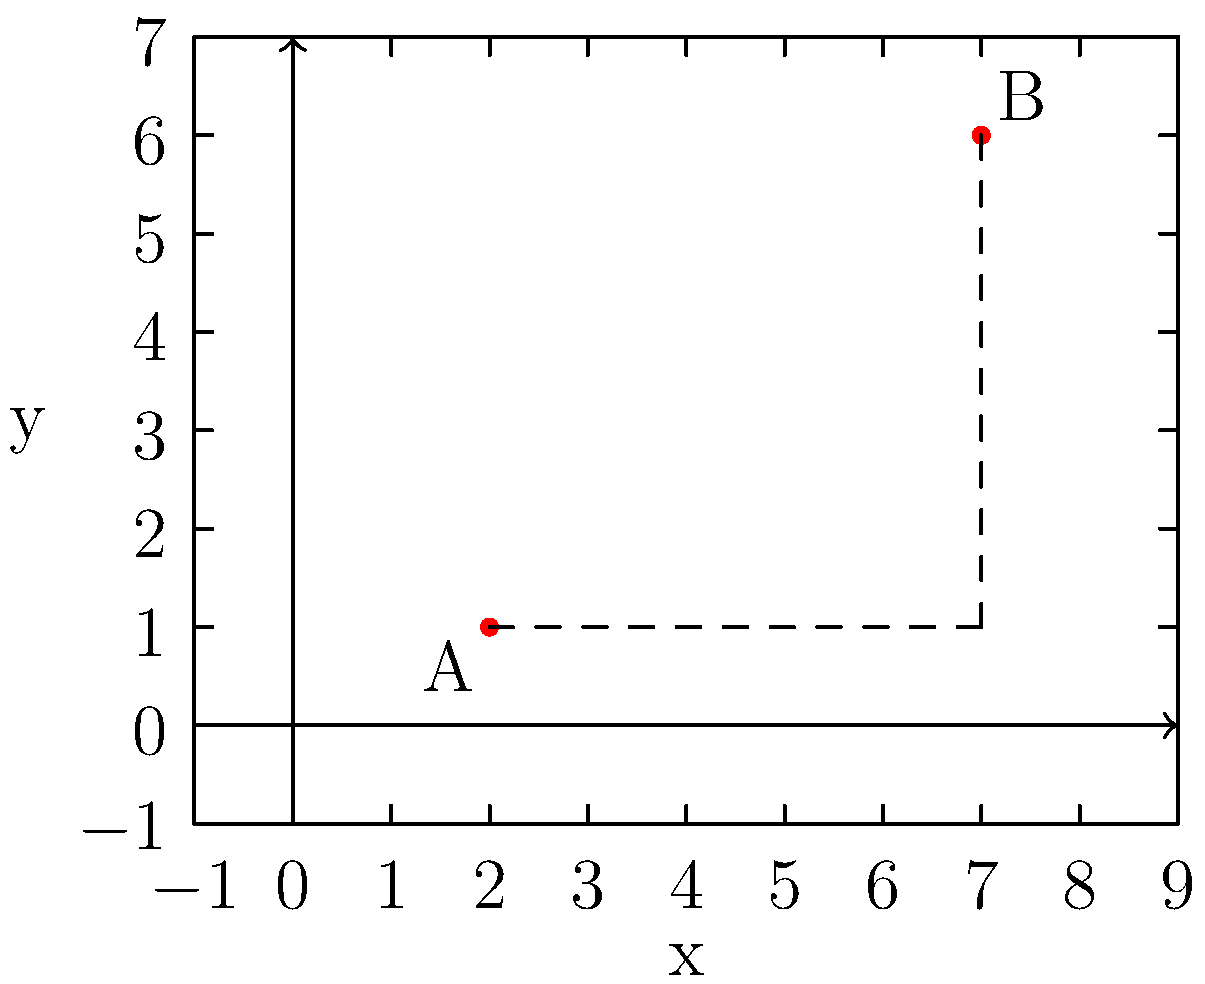In the coordinate plane above, points A and B are shown. If A has coordinates (2, 1) and B has coordinates (7, 6), what is the distance between these two points? Round your answer to two decimal places. To find the distance between two points on a coordinate plane, we can use the distance formula:

$$d = \sqrt{(x_2 - x_1)^2 + (y_2 - y_1)^2}$$

Where $(x_1, y_1)$ are the coordinates of the first point and $(x_2, y_2)$ are the coordinates of the second point.

Let's plug in our values:
A: $(x_1, y_1) = (2, 1)$
B: $(x_2, y_2) = (7, 6)$

Now, let's calculate:

1) First, find the differences:
   $x_2 - x_1 = 7 - 2 = 5$
   $y_2 - y_1 = 6 - 1 = 5$

2) Square these differences:
   $(x_2 - x_1)^2 = 5^2 = 25$
   $(y_2 - y_1)^2 = 5^2 = 25$

3) Add the squared differences:
   $25 + 25 = 50$

4) Take the square root:
   $d = \sqrt{50}$

5) Simplify:
   $d = 5\sqrt{2} \approx 7.07$

6) Round to two decimal places:
   $d \approx 7.07$

Therefore, the distance between points A and B is approximately 7.07 units.
Answer: 7.07 units 